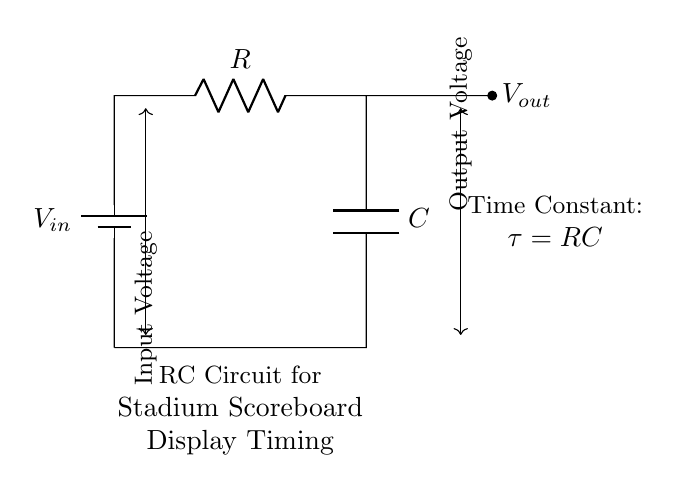What is the input voltage in this circuit? The input voltage is indicated by the label V_in connected to the positive terminal of the battery.
Answer: V_in What does the capacitor represent in this RC circuit? The capacitor, labeled C, is used for storing charge and influencing the timing characteristics in the RC circuit.
Answer: Timing component What is the output voltage read from the circuit? The output voltage is denoted as V_out on the right side of the circuit, which is what the circuit outputs after the capacitor discharges.
Answer: V_out What is the time constant formula for this RC circuit? The time constant is calculated using the formula τ = RC, where R is the resistance and C is the capacitance.
Answer: τ = RC How do the resistor and capacitor affect the timing in this circuit? The resistor (R) limits the current flow, while the capacitor (C) determines how quickly it can charge or discharge, together affecting the overall timing.
Answer: Inverse relation What happens when the capacitor fully charges? When the capacitor is fully charged, the output voltage V_out equals the input voltage V_in, and no current flows through the circuit.
Answer: V_out = V_in How is the relationship between voltage and time represented in an RC circuit? In an RC circuit, the relationship is typically represented by an exponential curve, showing how the voltage changes over time as the capacitor charges or discharges.
Answer: Exponential curve 